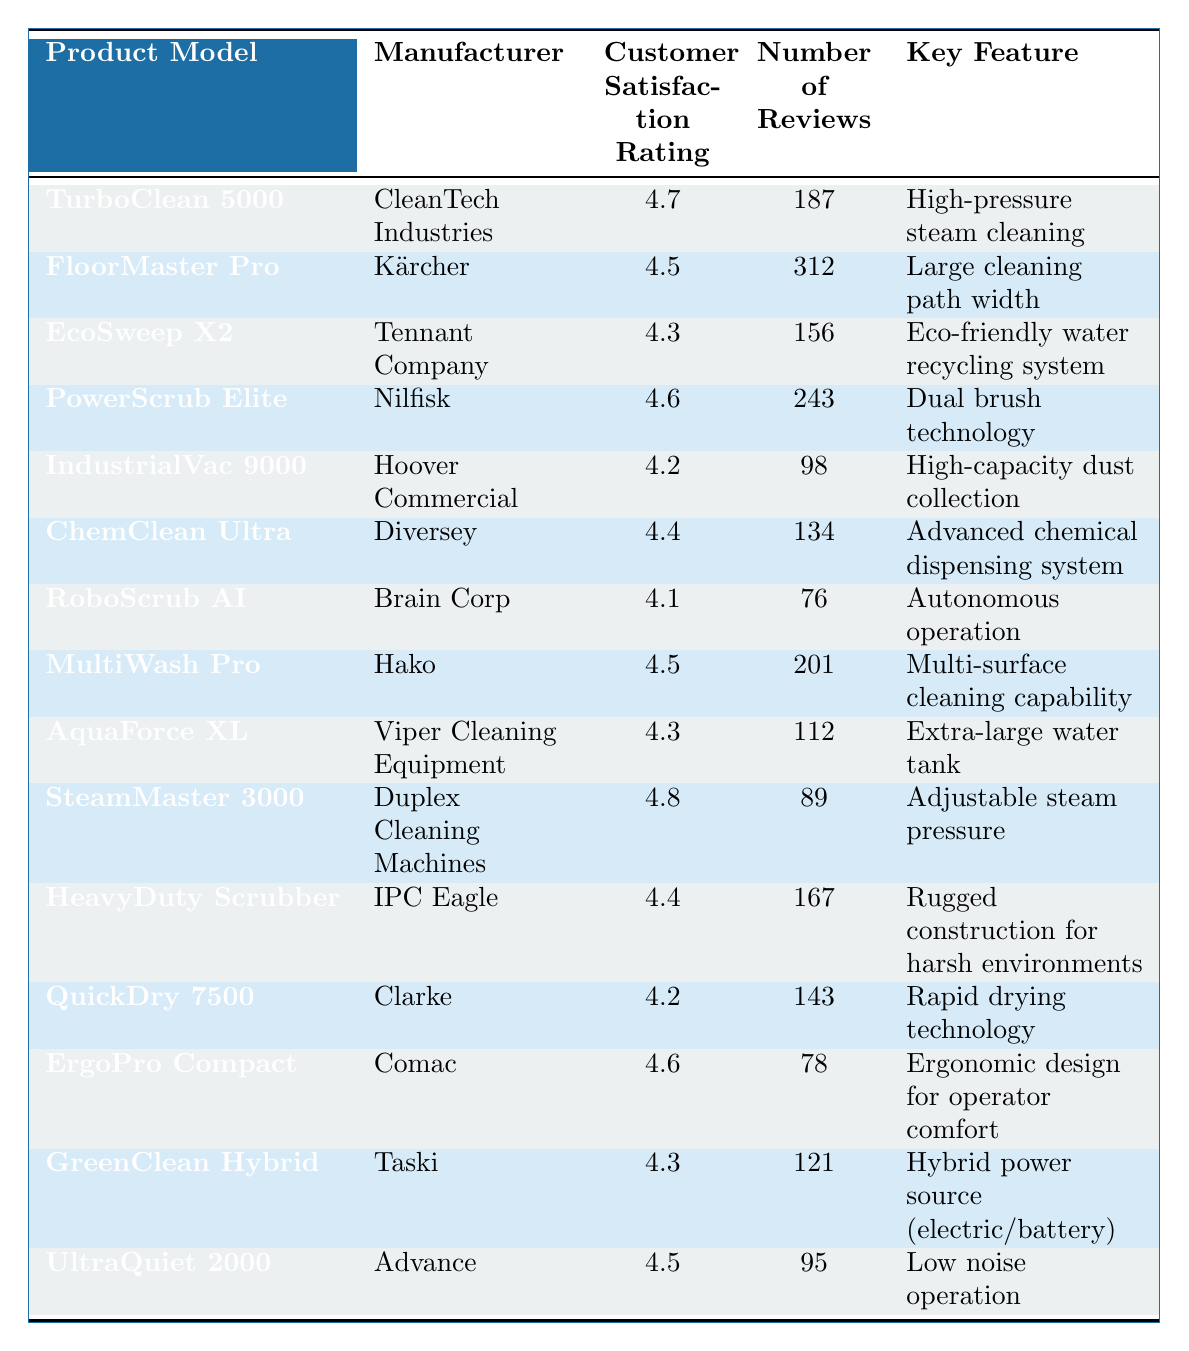What is the customer satisfaction rating for the TurboClean 5000? The TurboClean 5000 has a customer satisfaction rating of 4.7, which is directly stated in the table.
Answer: 4.7 Which product has the highest number of reviews? The FloorMaster Pro has the highest number of reviews, totaling 312, as shown in the table.
Answer: FloorMaster Pro How many products have a customer satisfaction rating of 4.4 or higher? There are 8 products with a customer satisfaction rating of 4.4 or higher: TurboClean 5000, FloorMaster Pro, PowerScrub Elite, ChemClean Ultra, SteamMaster 3000, HeavyDuty Scrubber, ErgoPro Compact, and UltraQuiet 2000.
Answer: 8 What is the key feature of the EcoSweep X2? The EcoSweep X2 features an eco-friendly water recycling system, as specified in the table.
Answer: Eco-friendly water recycling system Which product has the lowest customer satisfaction rating? The RoboScrub AI has the lowest customer satisfaction rating of 4.1, which is clearly listed in the table.
Answer: RoboScrub AI What is the average customer satisfaction rating of all products? The ratings sum to 66.1 across the 15 products. Dividing by 15 gives an average of 4.41.
Answer: 4.41 Is the HeavyDuty Scrubber rated higher than the IndustrialVac 9000? Yes, the HeavyDuty Scrubber has a rating of 4.4, which is higher than the IndustrialVac 9000's rating of 4.2 as shown in the table.
Answer: Yes Which products are from the manufacturer "Nilfisk"? The PowerScrub Elite is the only product listed under the manufacturer Nilfisk.
Answer: PowerScrub Elite How many products have a key feature related to environmental friendliness? There are 3 products with environmentally friendly features: EcoSweep X2, GreenClean Hybrid, and TurboClean 5000.
Answer: 3 What is the difference in customer satisfaction ratings between the highest and lowest rated products? The highest rating is 4.8 (SteamMaster 3000) and the lowest is 4.1 (RoboScrub AI). The difference is 4.8 - 4.1 = 0.7.
Answer: 0.7 